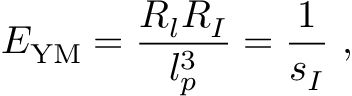<formula> <loc_0><loc_0><loc_500><loc_500>E _ { Y M } = \frac { R _ { l } R _ { I } } { l _ { p } ^ { 3 } } = \frac { 1 } { s _ { I } } \ ,</formula> 